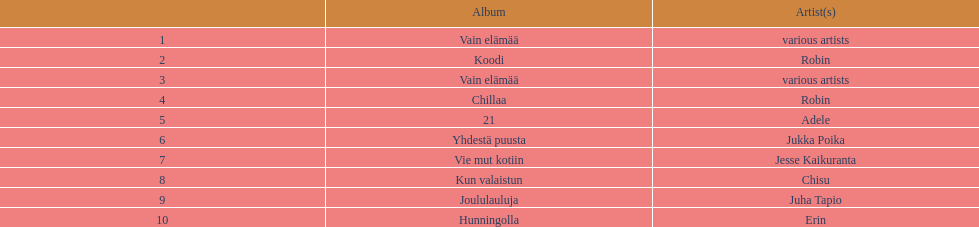What was the top selling album in this year? Vain elämää. 